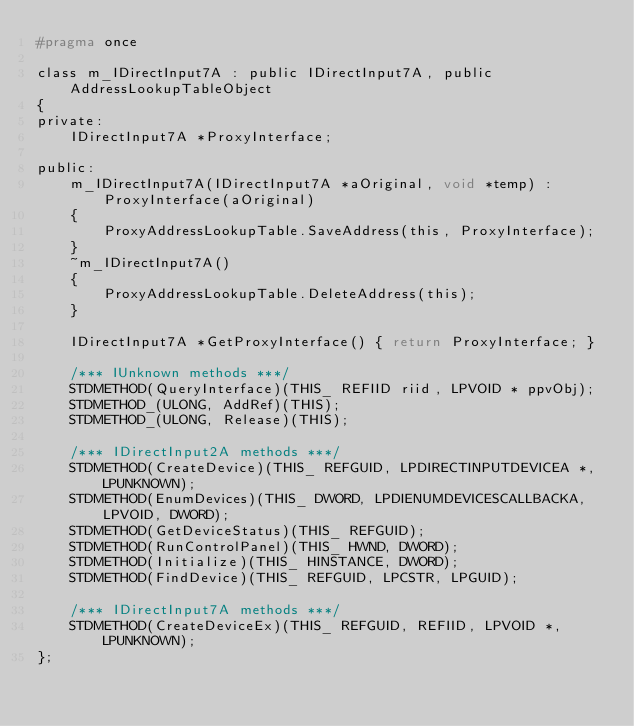<code> <loc_0><loc_0><loc_500><loc_500><_C_>#pragma once

class m_IDirectInput7A : public IDirectInput7A, public AddressLookupTableObject
{
private:
	IDirectInput7A *ProxyInterface;

public:
	m_IDirectInput7A(IDirectInput7A *aOriginal, void *temp) : ProxyInterface(aOriginal)
	{
		ProxyAddressLookupTable.SaveAddress(this, ProxyInterface);
	}
	~m_IDirectInput7A()
	{
		ProxyAddressLookupTable.DeleteAddress(this);
	}

	IDirectInput7A *GetProxyInterface() { return ProxyInterface; }

	/*** IUnknown methods ***/
	STDMETHOD(QueryInterface)(THIS_ REFIID riid, LPVOID * ppvObj);
	STDMETHOD_(ULONG, AddRef)(THIS);
	STDMETHOD_(ULONG, Release)(THIS);

	/*** IDirectInput2A methods ***/
	STDMETHOD(CreateDevice)(THIS_ REFGUID, LPDIRECTINPUTDEVICEA *, LPUNKNOWN);
	STDMETHOD(EnumDevices)(THIS_ DWORD, LPDIENUMDEVICESCALLBACKA, LPVOID, DWORD);
	STDMETHOD(GetDeviceStatus)(THIS_ REFGUID);
	STDMETHOD(RunControlPanel)(THIS_ HWND, DWORD);
	STDMETHOD(Initialize)(THIS_ HINSTANCE, DWORD);
	STDMETHOD(FindDevice)(THIS_ REFGUID, LPCSTR, LPGUID);

	/*** IDirectInput7A methods ***/
	STDMETHOD(CreateDeviceEx)(THIS_ REFGUID, REFIID, LPVOID *, LPUNKNOWN);
};
</code> 